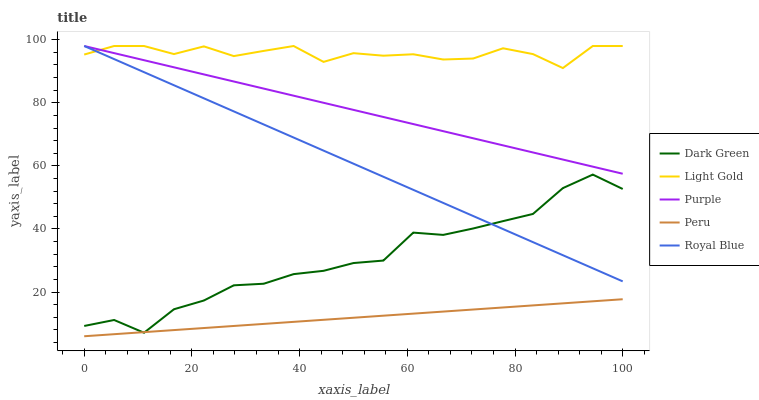Does Peru have the minimum area under the curve?
Answer yes or no. Yes. Does Light Gold have the maximum area under the curve?
Answer yes or no. Yes. Does Royal Blue have the minimum area under the curve?
Answer yes or no. No. Does Royal Blue have the maximum area under the curve?
Answer yes or no. No. Is Peru the smoothest?
Answer yes or no. Yes. Is Dark Green the roughest?
Answer yes or no. Yes. Is Royal Blue the smoothest?
Answer yes or no. No. Is Royal Blue the roughest?
Answer yes or no. No. Does Peru have the lowest value?
Answer yes or no. Yes. Does Royal Blue have the lowest value?
Answer yes or no. No. Does Light Gold have the highest value?
Answer yes or no. Yes. Does Peru have the highest value?
Answer yes or no. No. Is Dark Green less than Light Gold?
Answer yes or no. Yes. Is Purple greater than Dark Green?
Answer yes or no. Yes. Does Royal Blue intersect Purple?
Answer yes or no. Yes. Is Royal Blue less than Purple?
Answer yes or no. No. Is Royal Blue greater than Purple?
Answer yes or no. No. Does Dark Green intersect Light Gold?
Answer yes or no. No. 